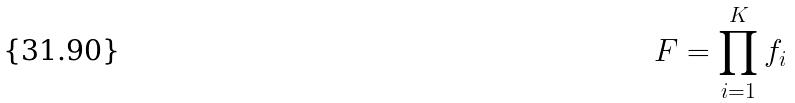Convert formula to latex. <formula><loc_0><loc_0><loc_500><loc_500>F = \prod _ { i = 1 } ^ { K } f _ { i }</formula> 